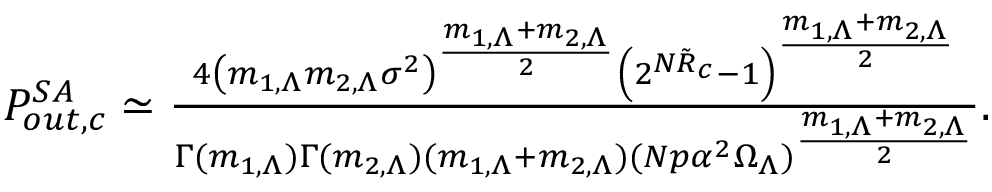<formula> <loc_0><loc_0><loc_500><loc_500>\begin{array} { r } { P _ { o u t , c } ^ { S A } \simeq \frac { 4 \left ( m _ { 1 , \Lambda } m _ { 2 , \Lambda } \sigma ^ { 2 } \right ) ^ { \frac { m _ { 1 , \Lambda } + m _ { 2 , \Lambda } } { 2 } } \left ( 2 ^ { N \tilde { R } _ { c } } - 1 \right ) ^ { \frac { m _ { 1 , \Lambda } + m _ { 2 , \Lambda } } { 2 } } } { \Gamma ( m _ { 1 , \Lambda } ) \Gamma ( m _ { 2 , \Lambda } ) ( m _ { 1 , \Lambda } + m _ { 2 , \Lambda } ) ( N p \alpha ^ { 2 } \Omega _ { \Lambda } ) ^ { \frac { m _ { 1 , \Lambda } + m _ { 2 , \Lambda } } { 2 } } } . } \end{array}</formula> 